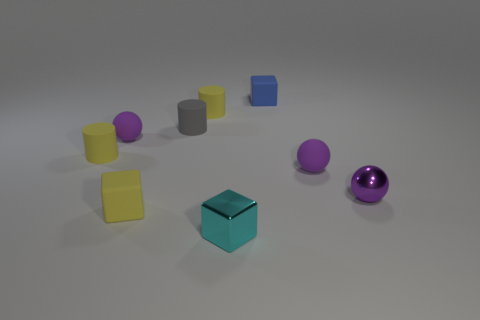How many things are tiny purple metal things or green matte things?
Your response must be concise. 1. Are there any other things that are the same material as the small blue block?
Keep it short and to the point. Yes. Are any yellow things visible?
Provide a short and direct response. Yes. Is the small thing that is in front of the yellow rubber block made of the same material as the yellow cube?
Provide a succinct answer. No. Is there another object of the same shape as the tiny blue thing?
Your response must be concise. Yes. Are there an equal number of cyan metal things that are to the left of the small cyan shiny object and tiny things?
Keep it short and to the point. No. There is a purple sphere behind the tiny matte object that is to the right of the blue matte cube; what is it made of?
Ensure brevity in your answer.  Rubber. The purple metallic thing is what shape?
Your response must be concise. Sphere. Are there an equal number of small purple matte objects left of the gray matte thing and tiny metallic objects right of the small purple metal ball?
Your answer should be compact. No. There is a small block that is to the right of the cyan block; does it have the same color as the matte sphere to the right of the shiny cube?
Offer a terse response. No. 